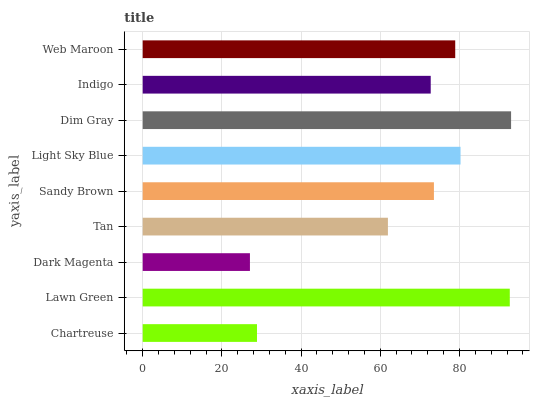Is Dark Magenta the minimum?
Answer yes or no. Yes. Is Dim Gray the maximum?
Answer yes or no. Yes. Is Lawn Green the minimum?
Answer yes or no. No. Is Lawn Green the maximum?
Answer yes or no. No. Is Lawn Green greater than Chartreuse?
Answer yes or no. Yes. Is Chartreuse less than Lawn Green?
Answer yes or no. Yes. Is Chartreuse greater than Lawn Green?
Answer yes or no. No. Is Lawn Green less than Chartreuse?
Answer yes or no. No. Is Sandy Brown the high median?
Answer yes or no. Yes. Is Sandy Brown the low median?
Answer yes or no. Yes. Is Indigo the high median?
Answer yes or no. No. Is Lawn Green the low median?
Answer yes or no. No. 